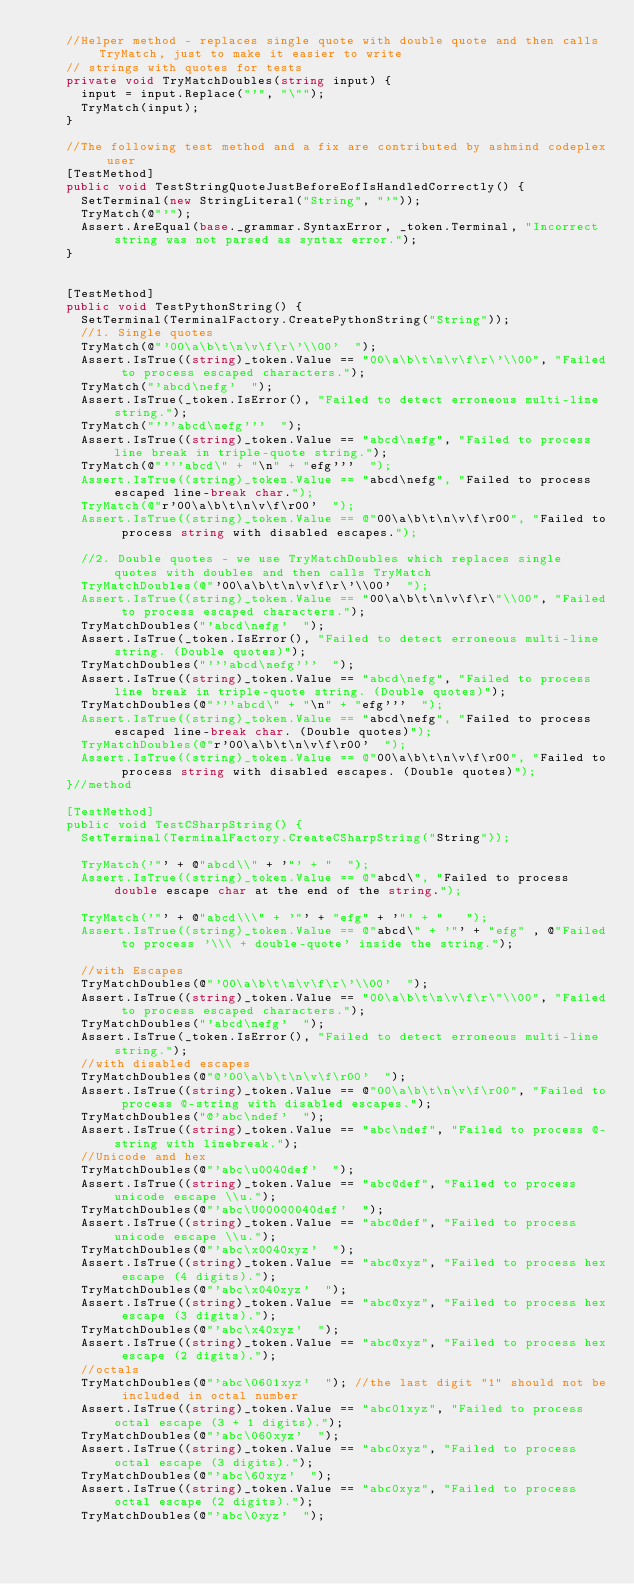Convert code to text. <code><loc_0><loc_0><loc_500><loc_500><_C#_>    //Helper method - replaces single quote with double quote and then calls TryMatch, just to make it easier to write
    // strings with quotes for tests
    private void TryMatchDoubles(string input) {
      input = input.Replace("'", "\"");
      TryMatch(input);
    }

    //The following test method and a fix are contributed by ashmind codeplex user
    [TestMethod]
    public void TestStringQuoteJustBeforeEofIsHandledCorrectly() {
      SetTerminal(new StringLiteral("String", "'"));
      TryMatch(@"'");
      Assert.AreEqual(base._grammar.SyntaxError, _token.Terminal, "Incorrect string was not parsed as syntax error.");
    }


    [TestMethod]
    public void TestPythonString() {
      SetTerminal(TerminalFactory.CreatePythonString("String"));
      //1. Single quotes
      TryMatch(@"'00\a\b\t\n\v\f\r\'\\00'  ");
      Assert.IsTrue((string)_token.Value == "00\a\b\t\n\v\f\r\'\\00", "Failed to process escaped characters.");
      TryMatch("'abcd\nefg'  ");
      Assert.IsTrue(_token.IsError(), "Failed to detect erroneous multi-line string.");
      TryMatch("'''abcd\nefg'''  ");
      Assert.IsTrue((string)_token.Value == "abcd\nefg", "Failed to process line break in triple-quote string.");
      TryMatch(@"'''abcd\" + "\n" + "efg'''  ");
      Assert.IsTrue((string)_token.Value == "abcd\nefg", "Failed to process escaped line-break char.");
      TryMatch(@"r'00\a\b\t\n\v\f\r00'  ");
      Assert.IsTrue((string)_token.Value == @"00\a\b\t\n\v\f\r00", "Failed to process string with disabled escapes.");
      
      //2. Double quotes - we use TryMatchDoubles which replaces single quotes with doubles and then calls TryMatch
      TryMatchDoubles(@"'00\a\b\t\n\v\f\r\'\\00'  ");
      Assert.IsTrue((string)_token.Value == "00\a\b\t\n\v\f\r\"\\00", "Failed to process escaped characters.");
      TryMatchDoubles("'abcd\nefg'  ");
      Assert.IsTrue(_token.IsError(), "Failed to detect erroneous multi-line string. (Double quotes)");
      TryMatchDoubles("'''abcd\nefg'''  ");
      Assert.IsTrue((string)_token.Value == "abcd\nefg", "Failed to process line break in triple-quote string. (Double quotes)");
      TryMatchDoubles(@"'''abcd\" + "\n" + "efg'''  ");
      Assert.IsTrue((string)_token.Value == "abcd\nefg", "Failed to process escaped line-break char. (Double quotes)");
      TryMatchDoubles(@"r'00\a\b\t\n\v\f\r00'  ");
      Assert.IsTrue((string)_token.Value == @"00\a\b\t\n\v\f\r00", "Failed to process string with disabled escapes. (Double quotes)");
    }//method

    [TestMethod]
    public void TestCSharpString() {
      SetTerminal(TerminalFactory.CreateCSharpString("String"));

      TryMatch('"' + @"abcd\\" + '"' + "  ");
      Assert.IsTrue((string)_token.Value == @"abcd\", "Failed to process double escape char at the end of the string.");

      TryMatch('"' + @"abcd\\\" + '"' + "efg" + '"' + "   ");
      Assert.IsTrue((string)_token.Value == @"abcd\" + '"' + "efg" , @"Failed to process '\\\ + double-quote' inside the string.");

      //with Escapes
      TryMatchDoubles(@"'00\a\b\t\n\v\f\r\'\\00'  ");
      Assert.IsTrue((string)_token.Value == "00\a\b\t\n\v\f\r\"\\00", "Failed to process escaped characters.");
      TryMatchDoubles("'abcd\nefg'  ");
      Assert.IsTrue(_token.IsError(), "Failed to detect erroneous multi-line string.");
      //with disabled escapes
      TryMatchDoubles(@"@'00\a\b\t\n\v\f\r00'  ");
      Assert.IsTrue((string)_token.Value == @"00\a\b\t\n\v\f\r00", "Failed to process @-string with disabled escapes.");
      TryMatchDoubles("@'abc\ndef'  ");
      Assert.IsTrue((string)_token.Value == "abc\ndef", "Failed to process @-string with linebreak.");
      //Unicode and hex
      TryMatchDoubles(@"'abc\u0040def'  ");
      Assert.IsTrue((string)_token.Value == "abc@def", "Failed to process unicode escape \\u.");
      TryMatchDoubles(@"'abc\U00000040def'  ");
      Assert.IsTrue((string)_token.Value == "abc@def", "Failed to process unicode escape \\u.");
      TryMatchDoubles(@"'abc\x0040xyz'  ");
      Assert.IsTrue((string)_token.Value == "abc@xyz", "Failed to process hex escape (4 digits).");
      TryMatchDoubles(@"'abc\x040xyz'  ");
      Assert.IsTrue((string)_token.Value == "abc@xyz", "Failed to process hex escape (3 digits).");
      TryMatchDoubles(@"'abc\x40xyz'  ");
      Assert.IsTrue((string)_token.Value == "abc@xyz", "Failed to process hex escape (2 digits).");
      //octals
      TryMatchDoubles(@"'abc\0601xyz'  "); //the last digit "1" should not be included in octal number
      Assert.IsTrue((string)_token.Value == "abc01xyz", "Failed to process octal escape (3 + 1 digits).");
      TryMatchDoubles(@"'abc\060xyz'  ");
      Assert.IsTrue((string)_token.Value == "abc0xyz", "Failed to process octal escape (3 digits).");
      TryMatchDoubles(@"'abc\60xyz'  ");
      Assert.IsTrue((string)_token.Value == "abc0xyz", "Failed to process octal escape (2 digits).");
      TryMatchDoubles(@"'abc\0xyz'  ");</code> 